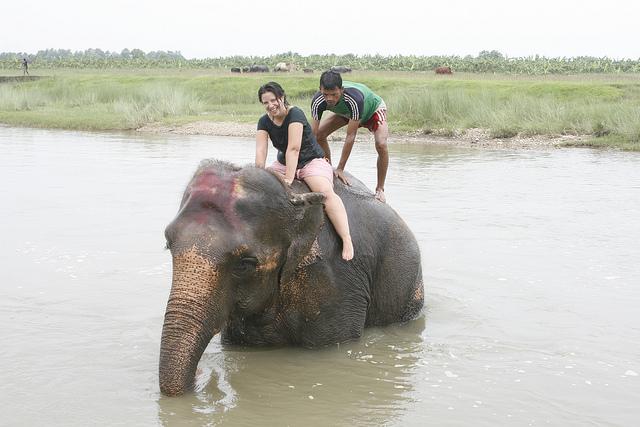How many people on the elephant?
Quick response, please. 2. Is the elephant hot?
Short answer required. No. Which person is the tourist?
Short answer required. Woman. 